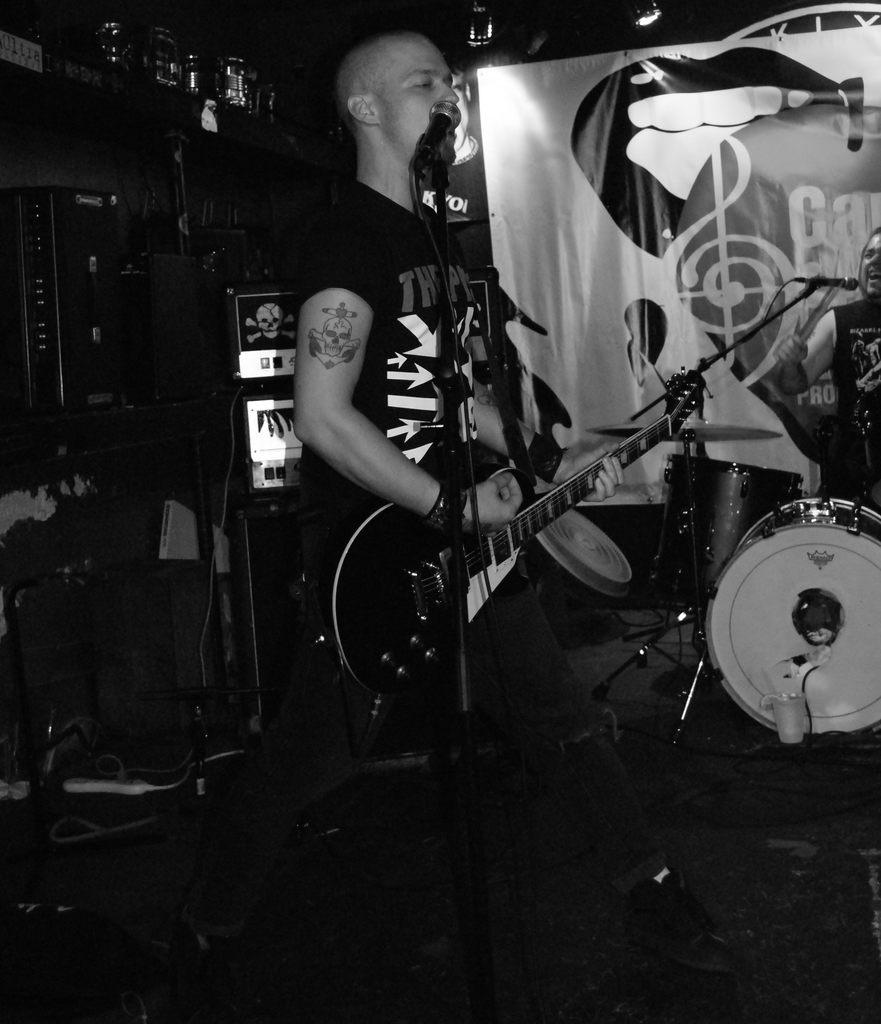What is the man in the image doing? The man is standing, playing a guitar, singing, and using a microphone. What instrument is the man playing in the image? The man is playing a guitar. How is the man's voice being amplified in the image? The man is using a microphone to amplify his voice. What type of nerve surgery is the man undergoing in the image? There is no indication of a nerve surgery or any medical procedure in the image; the man is playing a guitar, singing, and using a microphone. 